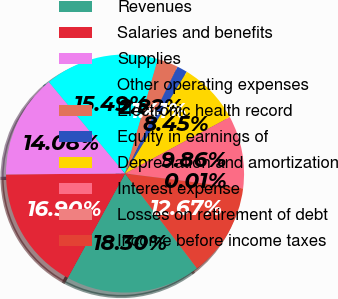Convert chart to OTSL. <chart><loc_0><loc_0><loc_500><loc_500><pie_chart><fcel>Revenues<fcel>Salaries and benefits<fcel>Supplies<fcel>Other operating expenses<fcel>Electronic health record<fcel>Equity in earnings of<fcel>Depreciation and amortization<fcel>Interest expense<fcel>Losses on retirement of debt<fcel>Income before income taxes<nl><fcel>18.3%<fcel>16.9%<fcel>14.08%<fcel>15.49%<fcel>2.82%<fcel>1.41%<fcel>8.45%<fcel>9.86%<fcel>0.01%<fcel>12.67%<nl></chart> 